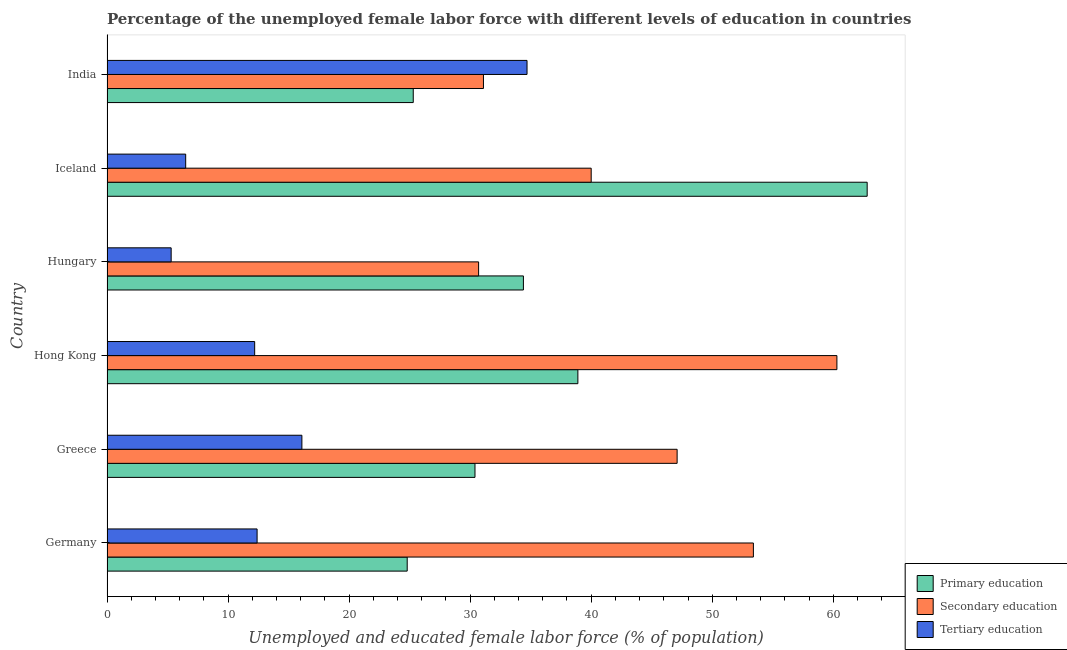How many different coloured bars are there?
Your answer should be very brief. 3. How many groups of bars are there?
Offer a terse response. 6. Are the number of bars per tick equal to the number of legend labels?
Provide a succinct answer. Yes. What is the label of the 1st group of bars from the top?
Your response must be concise. India. What is the percentage of female labor force who received secondary education in Germany?
Your response must be concise. 53.4. Across all countries, what is the maximum percentage of female labor force who received primary education?
Keep it short and to the point. 62.8. Across all countries, what is the minimum percentage of female labor force who received tertiary education?
Ensure brevity in your answer.  5.3. In which country was the percentage of female labor force who received tertiary education maximum?
Provide a short and direct response. India. In which country was the percentage of female labor force who received secondary education minimum?
Keep it short and to the point. Hungary. What is the total percentage of female labor force who received tertiary education in the graph?
Provide a succinct answer. 87.2. What is the difference between the percentage of female labor force who received tertiary education in Germany and that in Greece?
Ensure brevity in your answer.  -3.7. What is the difference between the percentage of female labor force who received primary education in Hong Kong and the percentage of female labor force who received tertiary education in India?
Offer a terse response. 4.2. What is the average percentage of female labor force who received primary education per country?
Provide a succinct answer. 36.1. What is the difference between the percentage of female labor force who received secondary education and percentage of female labor force who received primary education in Iceland?
Your answer should be very brief. -22.8. What is the ratio of the percentage of female labor force who received secondary education in Germany to that in Greece?
Your answer should be compact. 1.13. Is the percentage of female labor force who received tertiary education in Greece less than that in Hungary?
Your answer should be very brief. No. What is the difference between the highest and the second highest percentage of female labor force who received secondary education?
Give a very brief answer. 6.9. What does the 2nd bar from the top in India represents?
Give a very brief answer. Secondary education. Are all the bars in the graph horizontal?
Your answer should be compact. Yes. What is the difference between two consecutive major ticks on the X-axis?
Provide a succinct answer. 10. Where does the legend appear in the graph?
Ensure brevity in your answer.  Bottom right. How many legend labels are there?
Your answer should be compact. 3. What is the title of the graph?
Your answer should be compact. Percentage of the unemployed female labor force with different levels of education in countries. Does "Consumption Tax" appear as one of the legend labels in the graph?
Make the answer very short. No. What is the label or title of the X-axis?
Your response must be concise. Unemployed and educated female labor force (% of population). What is the label or title of the Y-axis?
Your answer should be compact. Country. What is the Unemployed and educated female labor force (% of population) in Primary education in Germany?
Your response must be concise. 24.8. What is the Unemployed and educated female labor force (% of population) in Secondary education in Germany?
Ensure brevity in your answer.  53.4. What is the Unemployed and educated female labor force (% of population) in Tertiary education in Germany?
Offer a terse response. 12.4. What is the Unemployed and educated female labor force (% of population) in Primary education in Greece?
Your response must be concise. 30.4. What is the Unemployed and educated female labor force (% of population) of Secondary education in Greece?
Your answer should be compact. 47.1. What is the Unemployed and educated female labor force (% of population) in Tertiary education in Greece?
Offer a terse response. 16.1. What is the Unemployed and educated female labor force (% of population) of Primary education in Hong Kong?
Offer a terse response. 38.9. What is the Unemployed and educated female labor force (% of population) of Secondary education in Hong Kong?
Provide a short and direct response. 60.3. What is the Unemployed and educated female labor force (% of population) of Tertiary education in Hong Kong?
Your answer should be compact. 12.2. What is the Unemployed and educated female labor force (% of population) in Primary education in Hungary?
Offer a terse response. 34.4. What is the Unemployed and educated female labor force (% of population) in Secondary education in Hungary?
Give a very brief answer. 30.7. What is the Unemployed and educated female labor force (% of population) of Tertiary education in Hungary?
Provide a succinct answer. 5.3. What is the Unemployed and educated female labor force (% of population) in Primary education in Iceland?
Your answer should be compact. 62.8. What is the Unemployed and educated female labor force (% of population) in Secondary education in Iceland?
Ensure brevity in your answer.  40. What is the Unemployed and educated female labor force (% of population) in Primary education in India?
Offer a very short reply. 25.3. What is the Unemployed and educated female labor force (% of population) in Secondary education in India?
Offer a terse response. 31.1. What is the Unemployed and educated female labor force (% of population) of Tertiary education in India?
Offer a very short reply. 34.7. Across all countries, what is the maximum Unemployed and educated female labor force (% of population) of Primary education?
Give a very brief answer. 62.8. Across all countries, what is the maximum Unemployed and educated female labor force (% of population) in Secondary education?
Provide a short and direct response. 60.3. Across all countries, what is the maximum Unemployed and educated female labor force (% of population) in Tertiary education?
Your answer should be very brief. 34.7. Across all countries, what is the minimum Unemployed and educated female labor force (% of population) of Primary education?
Give a very brief answer. 24.8. Across all countries, what is the minimum Unemployed and educated female labor force (% of population) of Secondary education?
Give a very brief answer. 30.7. Across all countries, what is the minimum Unemployed and educated female labor force (% of population) of Tertiary education?
Make the answer very short. 5.3. What is the total Unemployed and educated female labor force (% of population) in Primary education in the graph?
Keep it short and to the point. 216.6. What is the total Unemployed and educated female labor force (% of population) of Secondary education in the graph?
Keep it short and to the point. 262.6. What is the total Unemployed and educated female labor force (% of population) in Tertiary education in the graph?
Provide a short and direct response. 87.2. What is the difference between the Unemployed and educated female labor force (% of population) of Primary education in Germany and that in Greece?
Ensure brevity in your answer.  -5.6. What is the difference between the Unemployed and educated female labor force (% of population) in Secondary education in Germany and that in Greece?
Your answer should be very brief. 6.3. What is the difference between the Unemployed and educated female labor force (% of population) in Primary education in Germany and that in Hong Kong?
Keep it short and to the point. -14.1. What is the difference between the Unemployed and educated female labor force (% of population) of Secondary education in Germany and that in Hong Kong?
Your answer should be very brief. -6.9. What is the difference between the Unemployed and educated female labor force (% of population) in Primary education in Germany and that in Hungary?
Your response must be concise. -9.6. What is the difference between the Unemployed and educated female labor force (% of population) of Secondary education in Germany and that in Hungary?
Provide a succinct answer. 22.7. What is the difference between the Unemployed and educated female labor force (% of population) in Tertiary education in Germany and that in Hungary?
Your answer should be compact. 7.1. What is the difference between the Unemployed and educated female labor force (% of population) in Primary education in Germany and that in Iceland?
Your answer should be compact. -38. What is the difference between the Unemployed and educated female labor force (% of population) of Tertiary education in Germany and that in Iceland?
Your answer should be compact. 5.9. What is the difference between the Unemployed and educated female labor force (% of population) of Secondary education in Germany and that in India?
Make the answer very short. 22.3. What is the difference between the Unemployed and educated female labor force (% of population) in Tertiary education in Germany and that in India?
Give a very brief answer. -22.3. What is the difference between the Unemployed and educated female labor force (% of population) in Primary education in Greece and that in Hong Kong?
Give a very brief answer. -8.5. What is the difference between the Unemployed and educated female labor force (% of population) in Secondary education in Greece and that in Hong Kong?
Your answer should be compact. -13.2. What is the difference between the Unemployed and educated female labor force (% of population) of Primary education in Greece and that in Hungary?
Give a very brief answer. -4. What is the difference between the Unemployed and educated female labor force (% of population) in Primary education in Greece and that in Iceland?
Provide a short and direct response. -32.4. What is the difference between the Unemployed and educated female labor force (% of population) in Secondary education in Greece and that in Iceland?
Your answer should be very brief. 7.1. What is the difference between the Unemployed and educated female labor force (% of population) in Primary education in Greece and that in India?
Provide a short and direct response. 5.1. What is the difference between the Unemployed and educated female labor force (% of population) in Tertiary education in Greece and that in India?
Your answer should be very brief. -18.6. What is the difference between the Unemployed and educated female labor force (% of population) in Primary education in Hong Kong and that in Hungary?
Make the answer very short. 4.5. What is the difference between the Unemployed and educated female labor force (% of population) of Secondary education in Hong Kong and that in Hungary?
Give a very brief answer. 29.6. What is the difference between the Unemployed and educated female labor force (% of population) in Primary education in Hong Kong and that in Iceland?
Your answer should be compact. -23.9. What is the difference between the Unemployed and educated female labor force (% of population) of Secondary education in Hong Kong and that in Iceland?
Your answer should be very brief. 20.3. What is the difference between the Unemployed and educated female labor force (% of population) of Tertiary education in Hong Kong and that in Iceland?
Give a very brief answer. 5.7. What is the difference between the Unemployed and educated female labor force (% of population) in Secondary education in Hong Kong and that in India?
Provide a short and direct response. 29.2. What is the difference between the Unemployed and educated female labor force (% of population) in Tertiary education in Hong Kong and that in India?
Offer a very short reply. -22.5. What is the difference between the Unemployed and educated female labor force (% of population) in Primary education in Hungary and that in Iceland?
Offer a very short reply. -28.4. What is the difference between the Unemployed and educated female labor force (% of population) of Secondary education in Hungary and that in Iceland?
Your answer should be very brief. -9.3. What is the difference between the Unemployed and educated female labor force (% of population) of Primary education in Hungary and that in India?
Ensure brevity in your answer.  9.1. What is the difference between the Unemployed and educated female labor force (% of population) of Tertiary education in Hungary and that in India?
Ensure brevity in your answer.  -29.4. What is the difference between the Unemployed and educated female labor force (% of population) of Primary education in Iceland and that in India?
Offer a very short reply. 37.5. What is the difference between the Unemployed and educated female labor force (% of population) of Secondary education in Iceland and that in India?
Give a very brief answer. 8.9. What is the difference between the Unemployed and educated female labor force (% of population) of Tertiary education in Iceland and that in India?
Make the answer very short. -28.2. What is the difference between the Unemployed and educated female labor force (% of population) in Primary education in Germany and the Unemployed and educated female labor force (% of population) in Secondary education in Greece?
Your answer should be very brief. -22.3. What is the difference between the Unemployed and educated female labor force (% of population) in Secondary education in Germany and the Unemployed and educated female labor force (% of population) in Tertiary education in Greece?
Your answer should be very brief. 37.3. What is the difference between the Unemployed and educated female labor force (% of population) in Primary education in Germany and the Unemployed and educated female labor force (% of population) in Secondary education in Hong Kong?
Offer a very short reply. -35.5. What is the difference between the Unemployed and educated female labor force (% of population) of Secondary education in Germany and the Unemployed and educated female labor force (% of population) of Tertiary education in Hong Kong?
Ensure brevity in your answer.  41.2. What is the difference between the Unemployed and educated female labor force (% of population) in Primary education in Germany and the Unemployed and educated female labor force (% of population) in Secondary education in Hungary?
Offer a terse response. -5.9. What is the difference between the Unemployed and educated female labor force (% of population) of Primary education in Germany and the Unemployed and educated female labor force (% of population) of Tertiary education in Hungary?
Offer a very short reply. 19.5. What is the difference between the Unemployed and educated female labor force (% of population) of Secondary education in Germany and the Unemployed and educated female labor force (% of population) of Tertiary education in Hungary?
Offer a very short reply. 48.1. What is the difference between the Unemployed and educated female labor force (% of population) in Primary education in Germany and the Unemployed and educated female labor force (% of population) in Secondary education in Iceland?
Provide a succinct answer. -15.2. What is the difference between the Unemployed and educated female labor force (% of population) in Primary education in Germany and the Unemployed and educated female labor force (% of population) in Tertiary education in Iceland?
Your answer should be compact. 18.3. What is the difference between the Unemployed and educated female labor force (% of population) of Secondary education in Germany and the Unemployed and educated female labor force (% of population) of Tertiary education in Iceland?
Ensure brevity in your answer.  46.9. What is the difference between the Unemployed and educated female labor force (% of population) in Primary education in Germany and the Unemployed and educated female labor force (% of population) in Secondary education in India?
Keep it short and to the point. -6.3. What is the difference between the Unemployed and educated female labor force (% of population) of Primary education in Germany and the Unemployed and educated female labor force (% of population) of Tertiary education in India?
Keep it short and to the point. -9.9. What is the difference between the Unemployed and educated female labor force (% of population) of Primary education in Greece and the Unemployed and educated female labor force (% of population) of Secondary education in Hong Kong?
Your response must be concise. -29.9. What is the difference between the Unemployed and educated female labor force (% of population) in Secondary education in Greece and the Unemployed and educated female labor force (% of population) in Tertiary education in Hong Kong?
Your answer should be very brief. 34.9. What is the difference between the Unemployed and educated female labor force (% of population) in Primary education in Greece and the Unemployed and educated female labor force (% of population) in Secondary education in Hungary?
Keep it short and to the point. -0.3. What is the difference between the Unemployed and educated female labor force (% of population) of Primary education in Greece and the Unemployed and educated female labor force (% of population) of Tertiary education in Hungary?
Make the answer very short. 25.1. What is the difference between the Unemployed and educated female labor force (% of population) of Secondary education in Greece and the Unemployed and educated female labor force (% of population) of Tertiary education in Hungary?
Your response must be concise. 41.8. What is the difference between the Unemployed and educated female labor force (% of population) of Primary education in Greece and the Unemployed and educated female labor force (% of population) of Secondary education in Iceland?
Keep it short and to the point. -9.6. What is the difference between the Unemployed and educated female labor force (% of population) in Primary education in Greece and the Unemployed and educated female labor force (% of population) in Tertiary education in Iceland?
Ensure brevity in your answer.  23.9. What is the difference between the Unemployed and educated female labor force (% of population) of Secondary education in Greece and the Unemployed and educated female labor force (% of population) of Tertiary education in Iceland?
Offer a very short reply. 40.6. What is the difference between the Unemployed and educated female labor force (% of population) of Primary education in Greece and the Unemployed and educated female labor force (% of population) of Secondary education in India?
Your answer should be very brief. -0.7. What is the difference between the Unemployed and educated female labor force (% of population) of Primary education in Greece and the Unemployed and educated female labor force (% of population) of Tertiary education in India?
Offer a terse response. -4.3. What is the difference between the Unemployed and educated female labor force (% of population) of Primary education in Hong Kong and the Unemployed and educated female labor force (% of population) of Secondary education in Hungary?
Offer a terse response. 8.2. What is the difference between the Unemployed and educated female labor force (% of population) in Primary education in Hong Kong and the Unemployed and educated female labor force (% of population) in Tertiary education in Hungary?
Provide a short and direct response. 33.6. What is the difference between the Unemployed and educated female labor force (% of population) of Secondary education in Hong Kong and the Unemployed and educated female labor force (% of population) of Tertiary education in Hungary?
Give a very brief answer. 55. What is the difference between the Unemployed and educated female labor force (% of population) in Primary education in Hong Kong and the Unemployed and educated female labor force (% of population) in Secondary education in Iceland?
Keep it short and to the point. -1.1. What is the difference between the Unemployed and educated female labor force (% of population) in Primary education in Hong Kong and the Unemployed and educated female labor force (% of population) in Tertiary education in Iceland?
Your response must be concise. 32.4. What is the difference between the Unemployed and educated female labor force (% of population) in Secondary education in Hong Kong and the Unemployed and educated female labor force (% of population) in Tertiary education in Iceland?
Offer a terse response. 53.8. What is the difference between the Unemployed and educated female labor force (% of population) of Secondary education in Hong Kong and the Unemployed and educated female labor force (% of population) of Tertiary education in India?
Make the answer very short. 25.6. What is the difference between the Unemployed and educated female labor force (% of population) of Primary education in Hungary and the Unemployed and educated female labor force (% of population) of Tertiary education in Iceland?
Give a very brief answer. 27.9. What is the difference between the Unemployed and educated female labor force (% of population) of Secondary education in Hungary and the Unemployed and educated female labor force (% of population) of Tertiary education in Iceland?
Provide a succinct answer. 24.2. What is the difference between the Unemployed and educated female labor force (% of population) of Primary education in Hungary and the Unemployed and educated female labor force (% of population) of Secondary education in India?
Keep it short and to the point. 3.3. What is the difference between the Unemployed and educated female labor force (% of population) in Primary education in Iceland and the Unemployed and educated female labor force (% of population) in Secondary education in India?
Offer a very short reply. 31.7. What is the difference between the Unemployed and educated female labor force (% of population) of Primary education in Iceland and the Unemployed and educated female labor force (% of population) of Tertiary education in India?
Your answer should be compact. 28.1. What is the difference between the Unemployed and educated female labor force (% of population) in Secondary education in Iceland and the Unemployed and educated female labor force (% of population) in Tertiary education in India?
Provide a succinct answer. 5.3. What is the average Unemployed and educated female labor force (% of population) of Primary education per country?
Your response must be concise. 36.1. What is the average Unemployed and educated female labor force (% of population) in Secondary education per country?
Provide a succinct answer. 43.77. What is the average Unemployed and educated female labor force (% of population) of Tertiary education per country?
Provide a short and direct response. 14.53. What is the difference between the Unemployed and educated female labor force (% of population) of Primary education and Unemployed and educated female labor force (% of population) of Secondary education in Germany?
Keep it short and to the point. -28.6. What is the difference between the Unemployed and educated female labor force (% of population) of Primary education and Unemployed and educated female labor force (% of population) of Secondary education in Greece?
Offer a very short reply. -16.7. What is the difference between the Unemployed and educated female labor force (% of population) of Primary education and Unemployed and educated female labor force (% of population) of Tertiary education in Greece?
Provide a succinct answer. 14.3. What is the difference between the Unemployed and educated female labor force (% of population) of Primary education and Unemployed and educated female labor force (% of population) of Secondary education in Hong Kong?
Provide a short and direct response. -21.4. What is the difference between the Unemployed and educated female labor force (% of population) of Primary education and Unemployed and educated female labor force (% of population) of Tertiary education in Hong Kong?
Offer a very short reply. 26.7. What is the difference between the Unemployed and educated female labor force (% of population) in Secondary education and Unemployed and educated female labor force (% of population) in Tertiary education in Hong Kong?
Give a very brief answer. 48.1. What is the difference between the Unemployed and educated female labor force (% of population) in Primary education and Unemployed and educated female labor force (% of population) in Tertiary education in Hungary?
Provide a succinct answer. 29.1. What is the difference between the Unemployed and educated female labor force (% of population) of Secondary education and Unemployed and educated female labor force (% of population) of Tertiary education in Hungary?
Your answer should be compact. 25.4. What is the difference between the Unemployed and educated female labor force (% of population) of Primary education and Unemployed and educated female labor force (% of population) of Secondary education in Iceland?
Provide a succinct answer. 22.8. What is the difference between the Unemployed and educated female labor force (% of population) of Primary education and Unemployed and educated female labor force (% of population) of Tertiary education in Iceland?
Keep it short and to the point. 56.3. What is the difference between the Unemployed and educated female labor force (% of population) in Secondary education and Unemployed and educated female labor force (% of population) in Tertiary education in Iceland?
Your answer should be very brief. 33.5. What is the ratio of the Unemployed and educated female labor force (% of population) of Primary education in Germany to that in Greece?
Give a very brief answer. 0.82. What is the ratio of the Unemployed and educated female labor force (% of population) of Secondary education in Germany to that in Greece?
Provide a succinct answer. 1.13. What is the ratio of the Unemployed and educated female labor force (% of population) of Tertiary education in Germany to that in Greece?
Your response must be concise. 0.77. What is the ratio of the Unemployed and educated female labor force (% of population) in Primary education in Germany to that in Hong Kong?
Provide a short and direct response. 0.64. What is the ratio of the Unemployed and educated female labor force (% of population) in Secondary education in Germany to that in Hong Kong?
Your answer should be very brief. 0.89. What is the ratio of the Unemployed and educated female labor force (% of population) of Tertiary education in Germany to that in Hong Kong?
Keep it short and to the point. 1.02. What is the ratio of the Unemployed and educated female labor force (% of population) of Primary education in Germany to that in Hungary?
Your response must be concise. 0.72. What is the ratio of the Unemployed and educated female labor force (% of population) of Secondary education in Germany to that in Hungary?
Offer a very short reply. 1.74. What is the ratio of the Unemployed and educated female labor force (% of population) in Tertiary education in Germany to that in Hungary?
Give a very brief answer. 2.34. What is the ratio of the Unemployed and educated female labor force (% of population) in Primary education in Germany to that in Iceland?
Offer a very short reply. 0.39. What is the ratio of the Unemployed and educated female labor force (% of population) of Secondary education in Germany to that in Iceland?
Make the answer very short. 1.33. What is the ratio of the Unemployed and educated female labor force (% of population) in Tertiary education in Germany to that in Iceland?
Your response must be concise. 1.91. What is the ratio of the Unemployed and educated female labor force (% of population) of Primary education in Germany to that in India?
Give a very brief answer. 0.98. What is the ratio of the Unemployed and educated female labor force (% of population) of Secondary education in Germany to that in India?
Your answer should be very brief. 1.72. What is the ratio of the Unemployed and educated female labor force (% of population) in Tertiary education in Germany to that in India?
Make the answer very short. 0.36. What is the ratio of the Unemployed and educated female labor force (% of population) in Primary education in Greece to that in Hong Kong?
Give a very brief answer. 0.78. What is the ratio of the Unemployed and educated female labor force (% of population) in Secondary education in Greece to that in Hong Kong?
Keep it short and to the point. 0.78. What is the ratio of the Unemployed and educated female labor force (% of population) in Tertiary education in Greece to that in Hong Kong?
Your answer should be very brief. 1.32. What is the ratio of the Unemployed and educated female labor force (% of population) of Primary education in Greece to that in Hungary?
Keep it short and to the point. 0.88. What is the ratio of the Unemployed and educated female labor force (% of population) of Secondary education in Greece to that in Hungary?
Your answer should be very brief. 1.53. What is the ratio of the Unemployed and educated female labor force (% of population) of Tertiary education in Greece to that in Hungary?
Your answer should be compact. 3.04. What is the ratio of the Unemployed and educated female labor force (% of population) of Primary education in Greece to that in Iceland?
Provide a short and direct response. 0.48. What is the ratio of the Unemployed and educated female labor force (% of population) in Secondary education in Greece to that in Iceland?
Keep it short and to the point. 1.18. What is the ratio of the Unemployed and educated female labor force (% of population) of Tertiary education in Greece to that in Iceland?
Your answer should be compact. 2.48. What is the ratio of the Unemployed and educated female labor force (% of population) of Primary education in Greece to that in India?
Ensure brevity in your answer.  1.2. What is the ratio of the Unemployed and educated female labor force (% of population) of Secondary education in Greece to that in India?
Provide a short and direct response. 1.51. What is the ratio of the Unemployed and educated female labor force (% of population) in Tertiary education in Greece to that in India?
Offer a very short reply. 0.46. What is the ratio of the Unemployed and educated female labor force (% of population) of Primary education in Hong Kong to that in Hungary?
Give a very brief answer. 1.13. What is the ratio of the Unemployed and educated female labor force (% of population) of Secondary education in Hong Kong to that in Hungary?
Keep it short and to the point. 1.96. What is the ratio of the Unemployed and educated female labor force (% of population) in Tertiary education in Hong Kong to that in Hungary?
Make the answer very short. 2.3. What is the ratio of the Unemployed and educated female labor force (% of population) of Primary education in Hong Kong to that in Iceland?
Offer a very short reply. 0.62. What is the ratio of the Unemployed and educated female labor force (% of population) of Secondary education in Hong Kong to that in Iceland?
Make the answer very short. 1.51. What is the ratio of the Unemployed and educated female labor force (% of population) in Tertiary education in Hong Kong to that in Iceland?
Your response must be concise. 1.88. What is the ratio of the Unemployed and educated female labor force (% of population) in Primary education in Hong Kong to that in India?
Your answer should be very brief. 1.54. What is the ratio of the Unemployed and educated female labor force (% of population) in Secondary education in Hong Kong to that in India?
Your answer should be very brief. 1.94. What is the ratio of the Unemployed and educated female labor force (% of population) of Tertiary education in Hong Kong to that in India?
Your response must be concise. 0.35. What is the ratio of the Unemployed and educated female labor force (% of population) of Primary education in Hungary to that in Iceland?
Keep it short and to the point. 0.55. What is the ratio of the Unemployed and educated female labor force (% of population) in Secondary education in Hungary to that in Iceland?
Provide a short and direct response. 0.77. What is the ratio of the Unemployed and educated female labor force (% of population) in Tertiary education in Hungary to that in Iceland?
Provide a succinct answer. 0.82. What is the ratio of the Unemployed and educated female labor force (% of population) in Primary education in Hungary to that in India?
Provide a succinct answer. 1.36. What is the ratio of the Unemployed and educated female labor force (% of population) of Secondary education in Hungary to that in India?
Provide a succinct answer. 0.99. What is the ratio of the Unemployed and educated female labor force (% of population) in Tertiary education in Hungary to that in India?
Your response must be concise. 0.15. What is the ratio of the Unemployed and educated female labor force (% of population) in Primary education in Iceland to that in India?
Give a very brief answer. 2.48. What is the ratio of the Unemployed and educated female labor force (% of population) in Secondary education in Iceland to that in India?
Your answer should be compact. 1.29. What is the ratio of the Unemployed and educated female labor force (% of population) in Tertiary education in Iceland to that in India?
Your answer should be compact. 0.19. What is the difference between the highest and the second highest Unemployed and educated female labor force (% of population) of Primary education?
Make the answer very short. 23.9. What is the difference between the highest and the second highest Unemployed and educated female labor force (% of population) of Secondary education?
Your response must be concise. 6.9. What is the difference between the highest and the lowest Unemployed and educated female labor force (% of population) in Secondary education?
Your answer should be very brief. 29.6. What is the difference between the highest and the lowest Unemployed and educated female labor force (% of population) in Tertiary education?
Your response must be concise. 29.4. 